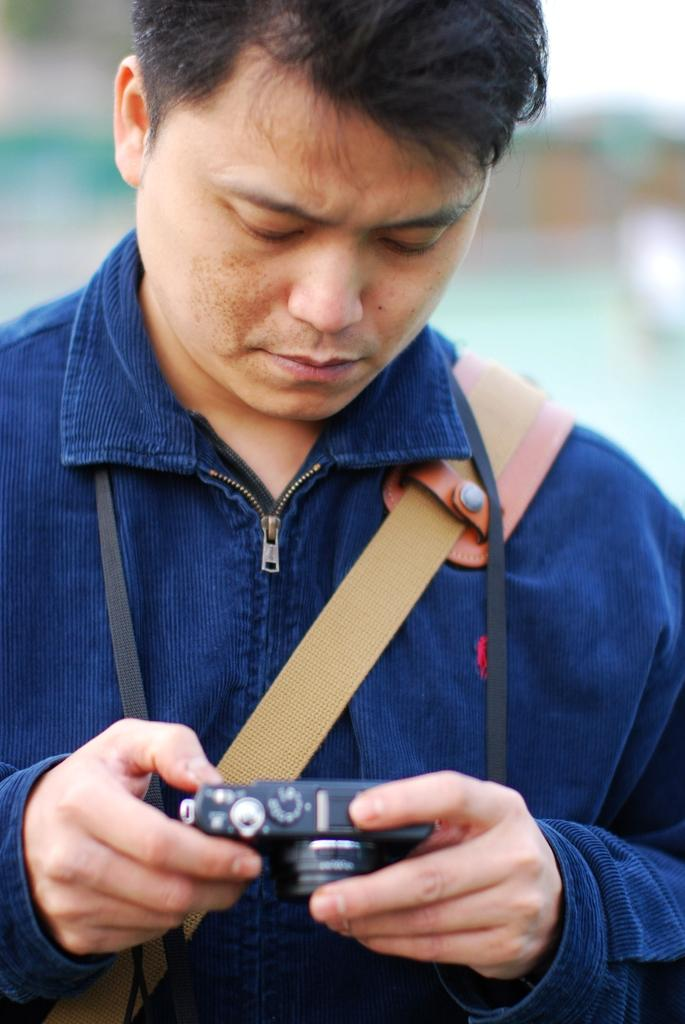Who is present in the image? There is a person in the image. What is the person wearing? The person is wearing a blue shirt. What is the person carrying in the image? The person is carrying a bag. What is the person holding in their hands? The person is holding a camera in their hands. What is causing the kittens to meow in the image? There are no kittens present in the image, so it is not possible to determine what might be causing them to meow. 